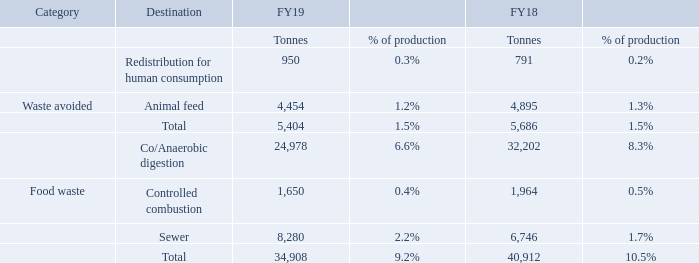Minimising our environmental impact
During FY19 we have undertaken energy audits across all our UK manufacturing sites as part of our Energy Savings Opportunity Scheme (‘ESOS’) compliance programme, which is a mandatory energy assessment scheme for UK organisations. Our progress on energy efficiency improvements remains good, and we have delivered a further 4.9% improvement in our primary energy per tonne of product against last year, and 26.5% over the last six years.
What is the total food waste for FY19? 34,908. What is the total food waste for FY18? 40,912. What was the animal feed waste avoided in FY19? 4,454. What was the change in the animal feed waste avoided from FY18 to FY19? 4,454 - 4,895
Answer: -441. What is the average redistribution for human consumption for FY18 and FY19? (950 + 791) / 2
Answer: 870.5. What is the average controlled combustion food waste for FY18 and FY19? (1,650 + 1,964) / 2
Answer: 1807. 